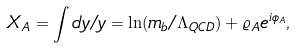Convert formula to latex. <formula><loc_0><loc_0><loc_500><loc_500>X _ { A } = \int d y / y = \ln ( m _ { b } / \Lambda _ { Q C D } ) + \varrho _ { A } e ^ { i \phi _ { A } } ,</formula> 